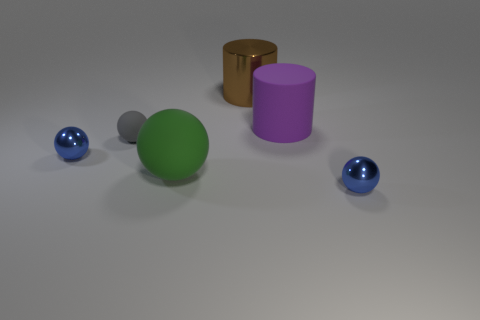Is the number of blue things that are to the left of the large purple rubber cylinder greater than the number of large objects that are to the left of the big metallic object?
Your response must be concise. No. Is there another rubber object of the same size as the purple object?
Provide a succinct answer. Yes. What is the size of the green ball left of the blue metal object that is to the right of the tiny blue sphere left of the brown shiny cylinder?
Ensure brevity in your answer.  Large. The big matte ball has what color?
Your answer should be very brief. Green. Are there more brown shiny cylinders that are to the left of the large purple matte object than large purple rubber cubes?
Offer a very short reply. Yes. There is a large purple rubber thing; how many blue metallic things are right of it?
Offer a terse response. 1. There is a blue ball that is on the left side of the big cylinder that is in front of the brown thing; are there any tiny metal spheres on the right side of it?
Give a very brief answer. Yes. Is the purple rubber cylinder the same size as the green matte sphere?
Offer a terse response. Yes. Are there an equal number of cylinders on the right side of the brown metallic object and small gray matte spheres in front of the big purple rubber thing?
Keep it short and to the point. Yes. There is a metal thing behind the big purple matte object; what is its shape?
Your answer should be very brief. Cylinder. 